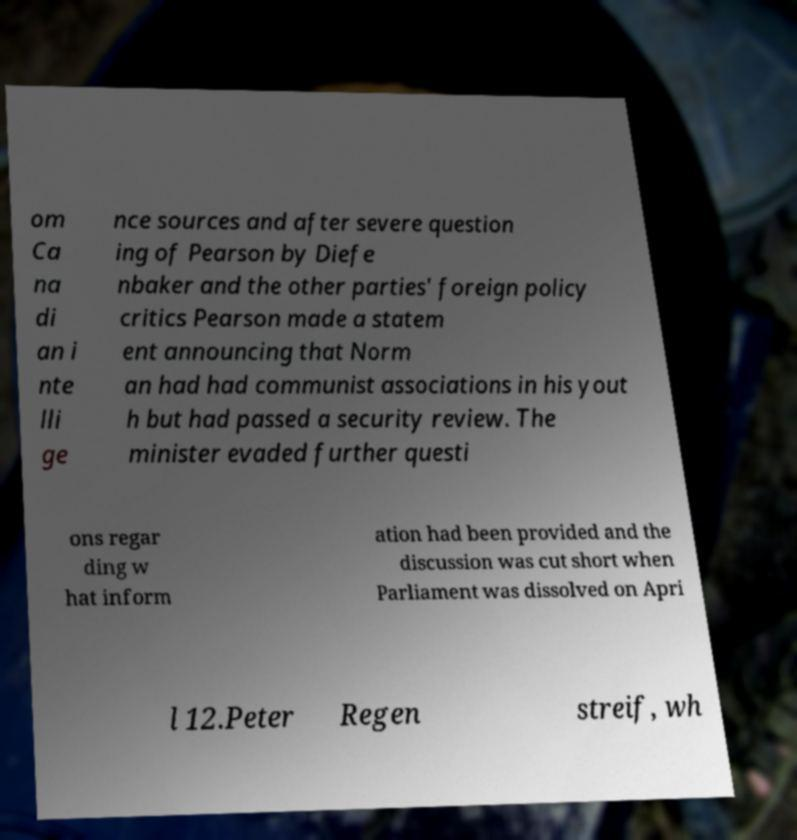Can you read and provide the text displayed in the image?This photo seems to have some interesting text. Can you extract and type it out for me? om Ca na di an i nte lli ge nce sources and after severe question ing of Pearson by Diefe nbaker and the other parties' foreign policy critics Pearson made a statem ent announcing that Norm an had had communist associations in his yout h but had passed a security review. The minister evaded further questi ons regar ding w hat inform ation had been provided and the discussion was cut short when Parliament was dissolved on Apri l 12.Peter Regen streif, wh 